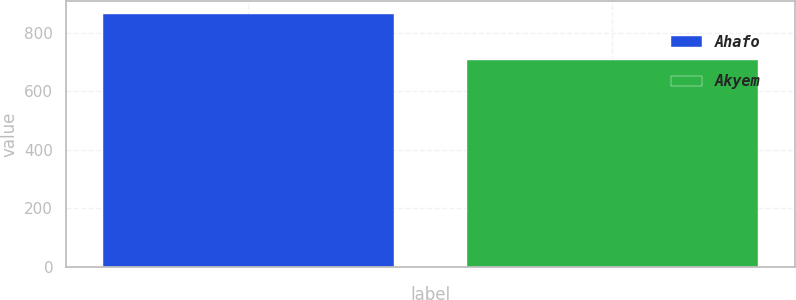Convert chart to OTSL. <chart><loc_0><loc_0><loc_500><loc_500><bar_chart><fcel>Ahafo<fcel>Akyem<nl><fcel>864<fcel>705<nl></chart> 